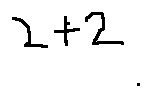<formula> <loc_0><loc_0><loc_500><loc_500>2 + 2</formula> 